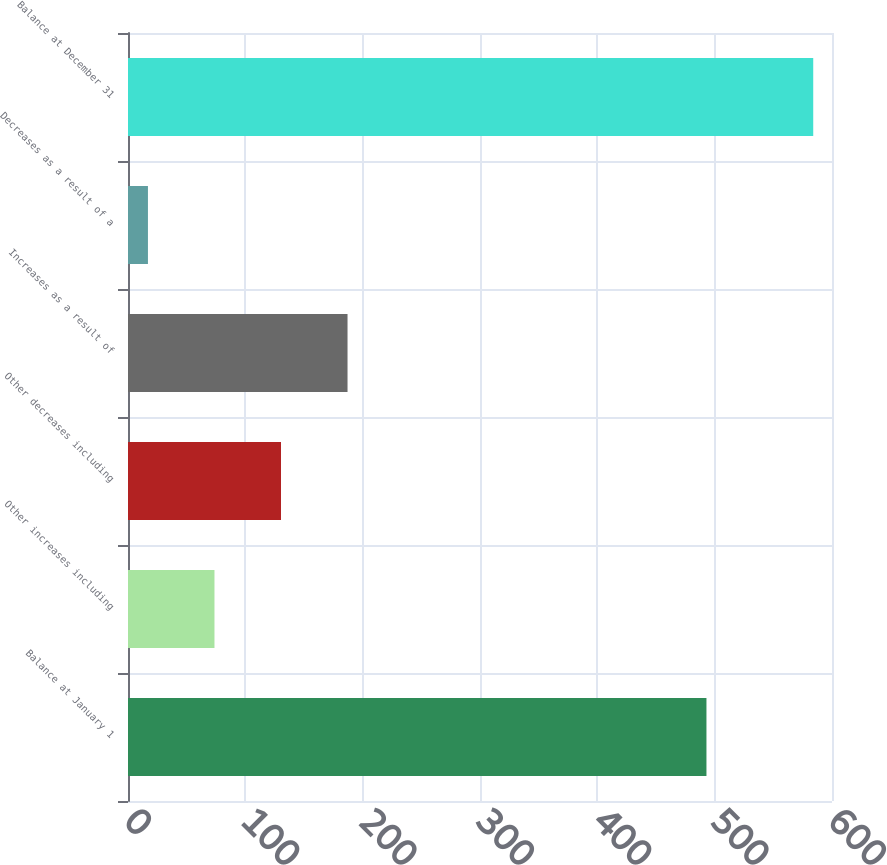<chart> <loc_0><loc_0><loc_500><loc_500><bar_chart><fcel>Balance at January 1<fcel>Other increases including<fcel>Other decreases including<fcel>Increases as a result of<fcel>Decreases as a result of a<fcel>Balance at December 31<nl><fcel>493<fcel>73.7<fcel>130.4<fcel>187.1<fcel>17<fcel>584<nl></chart> 